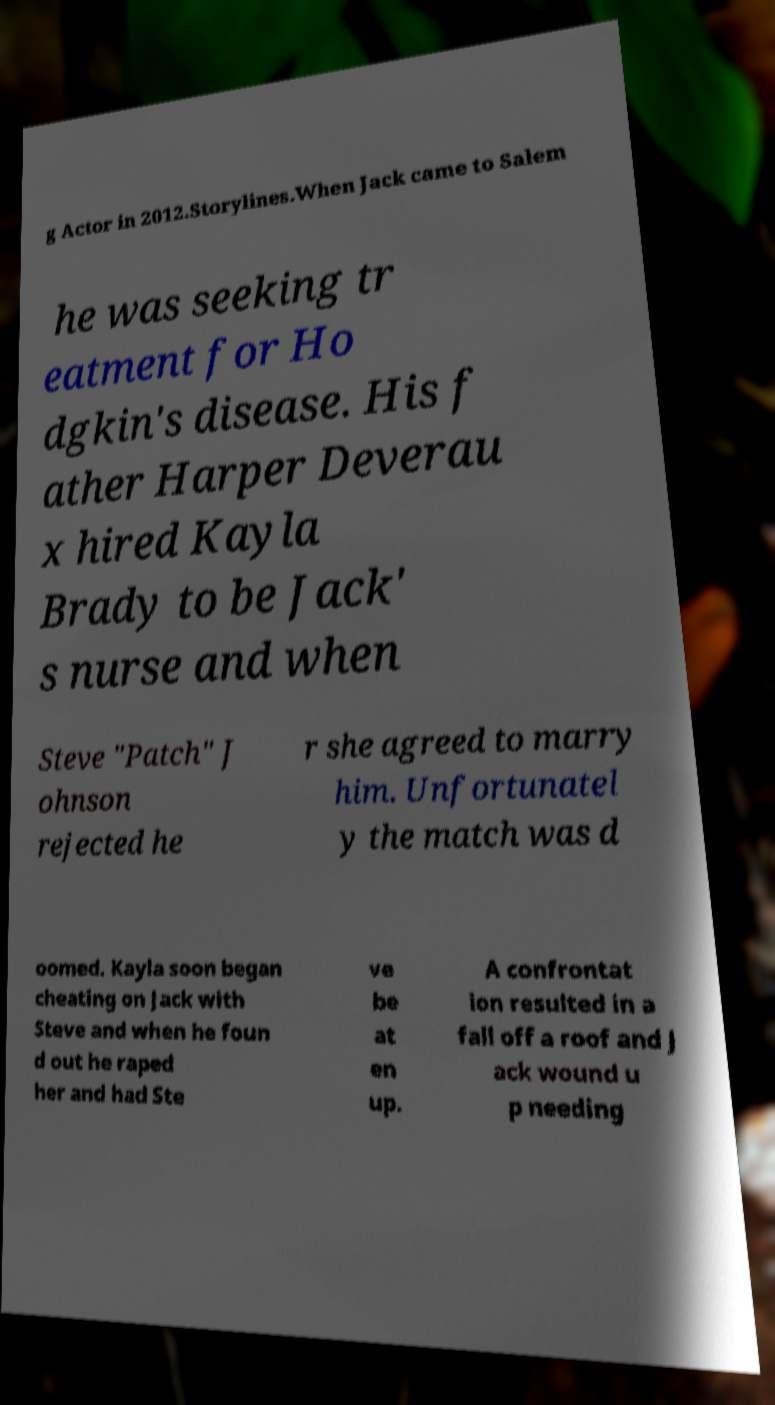Please read and relay the text visible in this image. What does it say? g Actor in 2012.Storylines.When Jack came to Salem he was seeking tr eatment for Ho dgkin's disease. His f ather Harper Deverau x hired Kayla Brady to be Jack' s nurse and when Steve "Patch" J ohnson rejected he r she agreed to marry him. Unfortunatel y the match was d oomed. Kayla soon began cheating on Jack with Steve and when he foun d out he raped her and had Ste ve be at en up. A confrontat ion resulted in a fall off a roof and J ack wound u p needing 